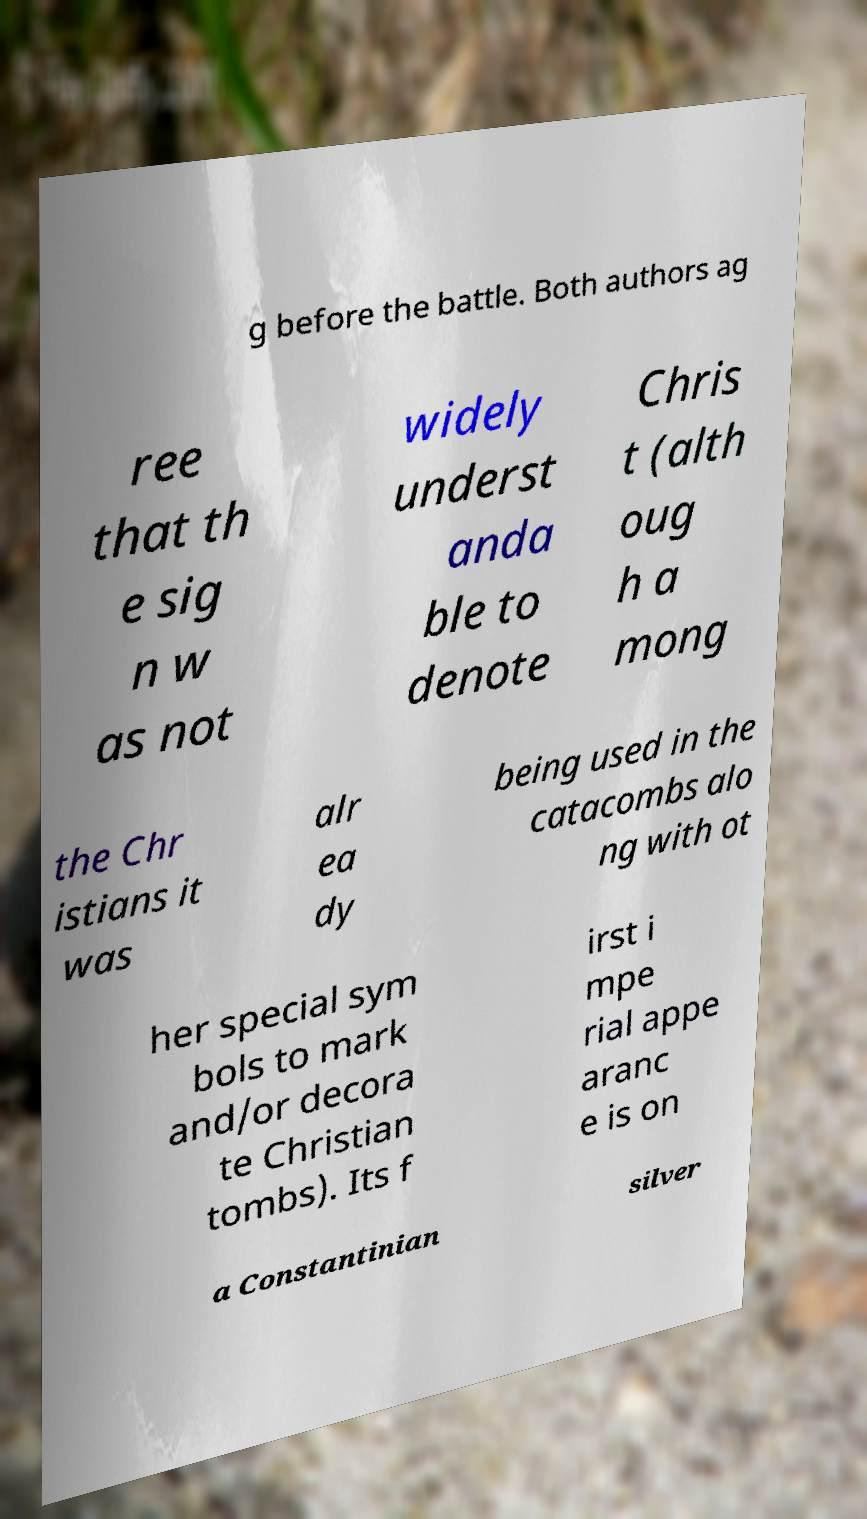What messages or text are displayed in this image? I need them in a readable, typed format. g before the battle. Both authors ag ree that th e sig n w as not widely underst anda ble to denote Chris t (alth oug h a mong the Chr istians it was alr ea dy being used in the catacombs alo ng with ot her special sym bols to mark and/or decora te Christian tombs). Its f irst i mpe rial appe aranc e is on a Constantinian silver 